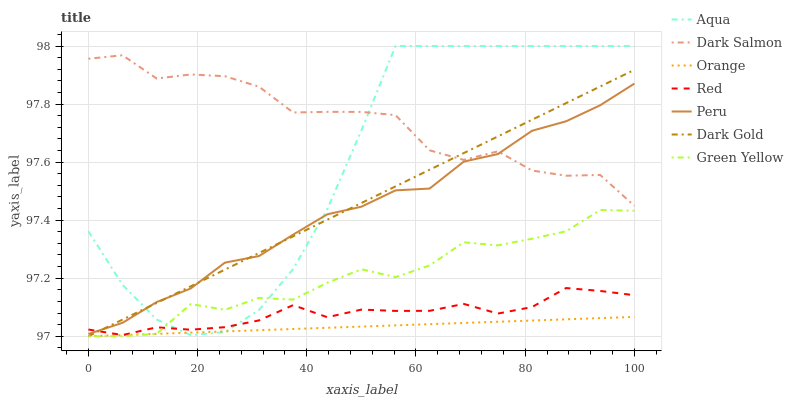Does Orange have the minimum area under the curve?
Answer yes or no. Yes. Does Dark Salmon have the maximum area under the curve?
Answer yes or no. Yes. Does Aqua have the minimum area under the curve?
Answer yes or no. No. Does Aqua have the maximum area under the curve?
Answer yes or no. No. Is Dark Gold the smoothest?
Answer yes or no. Yes. Is Dark Salmon the roughest?
Answer yes or no. Yes. Is Aqua the smoothest?
Answer yes or no. No. Is Aqua the roughest?
Answer yes or no. No. Does Dark Gold have the lowest value?
Answer yes or no. Yes. Does Aqua have the lowest value?
Answer yes or no. No. Does Aqua have the highest value?
Answer yes or no. Yes. Does Dark Salmon have the highest value?
Answer yes or no. No. Is Orange less than Peru?
Answer yes or no. Yes. Is Dark Salmon greater than Red?
Answer yes or no. Yes. Does Red intersect Aqua?
Answer yes or no. Yes. Is Red less than Aqua?
Answer yes or no. No. Is Red greater than Aqua?
Answer yes or no. No. Does Orange intersect Peru?
Answer yes or no. No. 